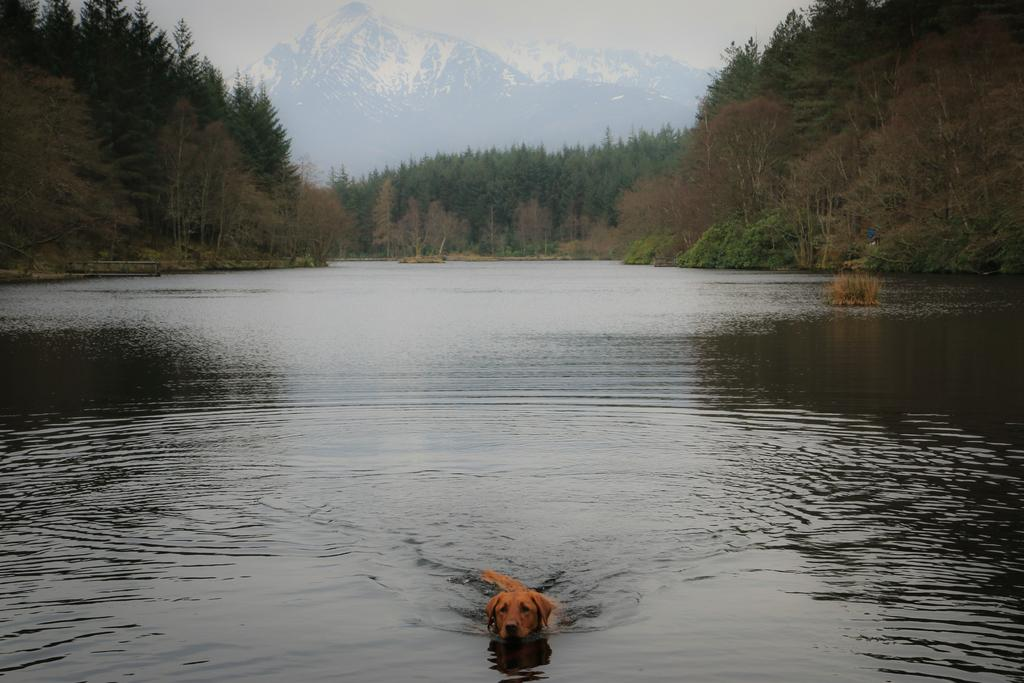What is located at the bottom of the image? There is a river at the bottom of the image. What can be seen in the river? There is a dog in the river. What type of vegetation is visible in the background of the image? There are trees in the background of the image. What type of geographical feature is visible in the background of the image? There are mountains in the background of the image. Where are the tomatoes being stored in the image? There are no tomatoes present in the image. What type of furniture is visible in the image? There is no furniture visible in the image. 